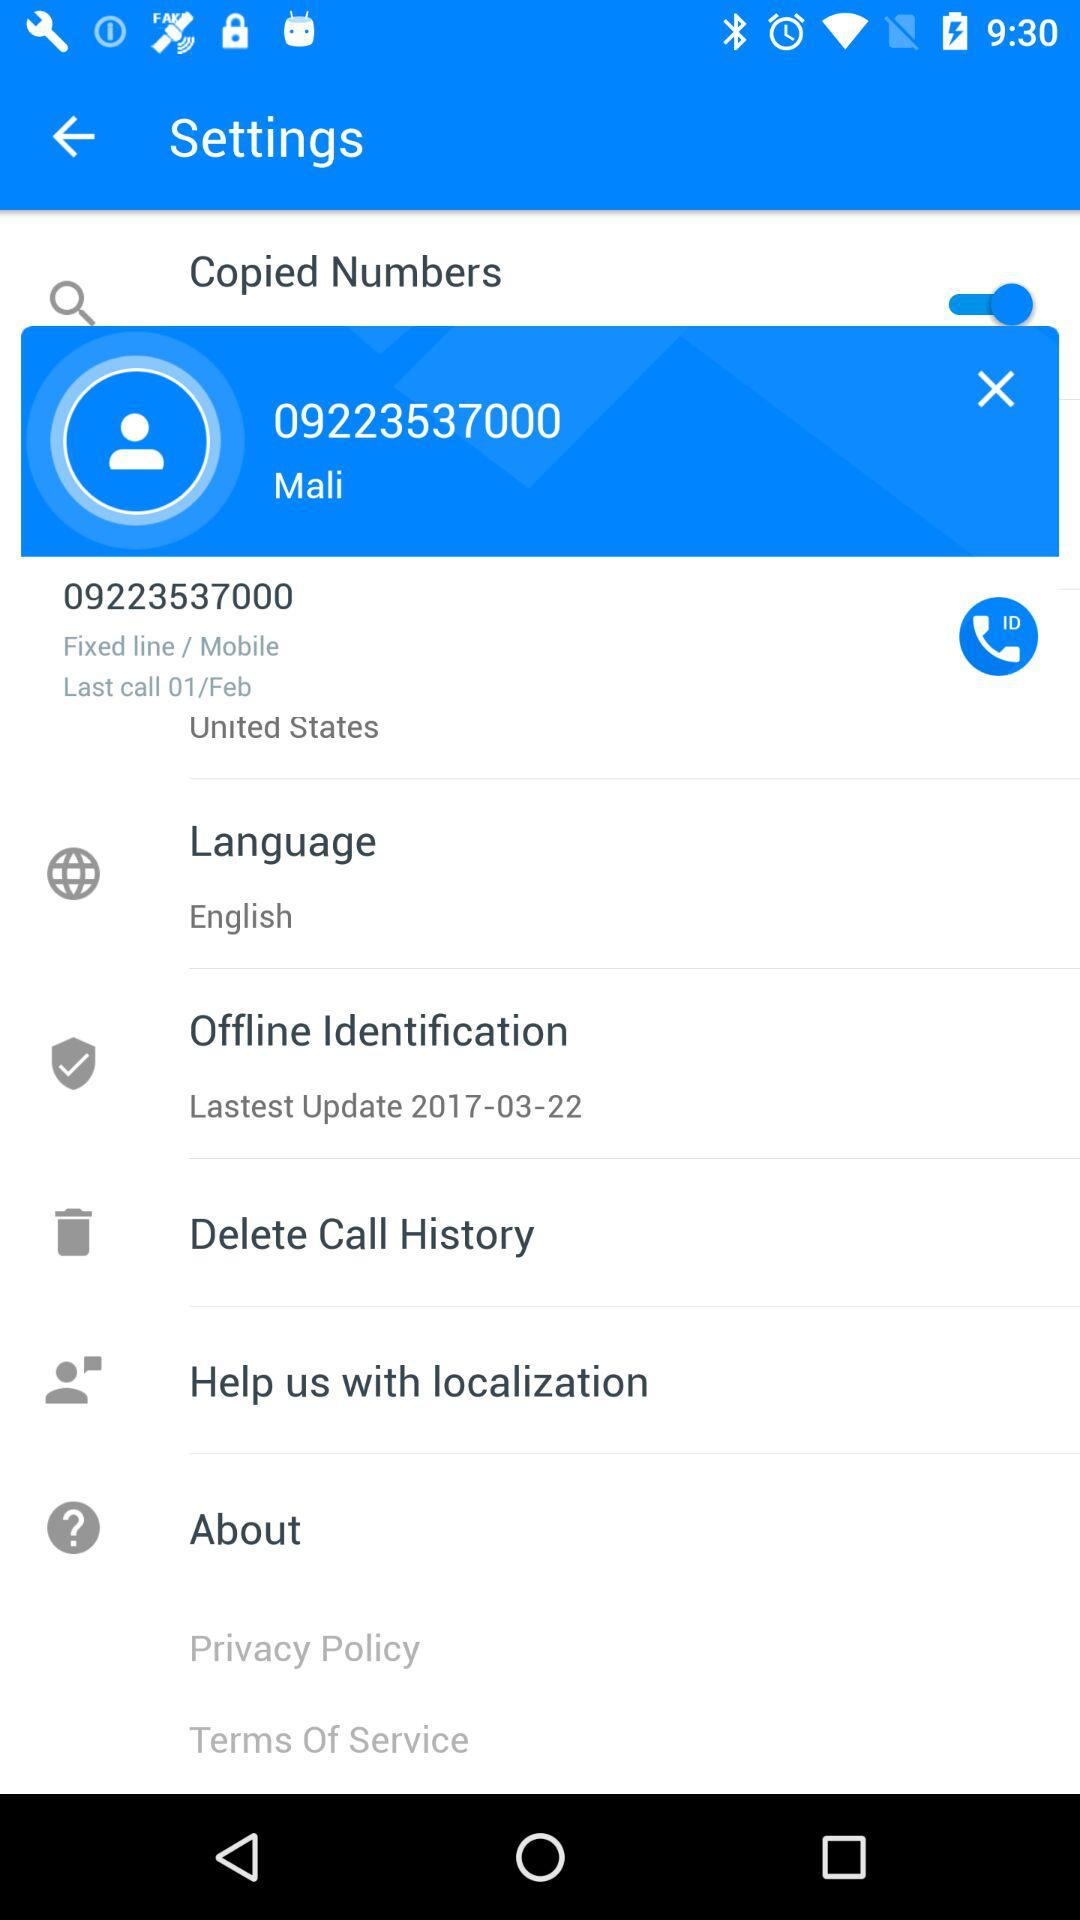When was the last time we made a phone call? The last time you made a phone call was on February 1. 